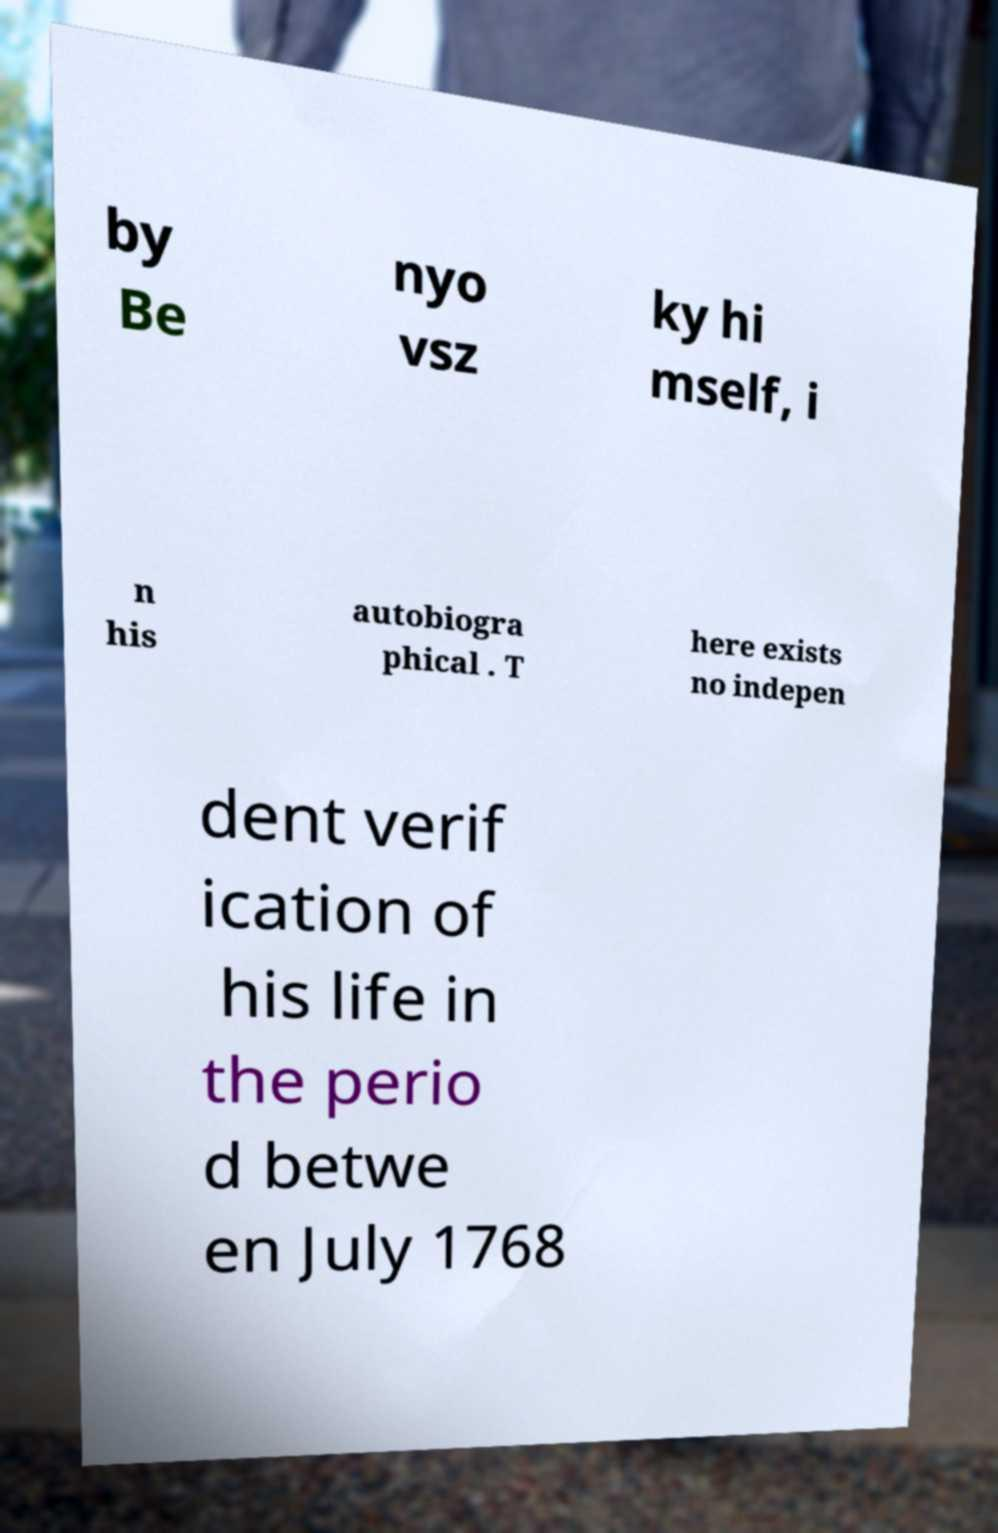Could you assist in decoding the text presented in this image and type it out clearly? by Be nyo vsz ky hi mself, i n his autobiogra phical . T here exists no indepen dent verif ication of his life in the perio d betwe en July 1768 